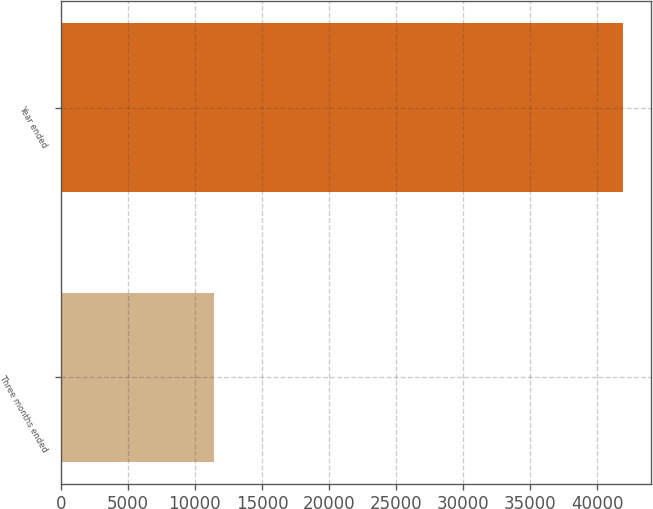<chart> <loc_0><loc_0><loc_500><loc_500><bar_chart><fcel>Three months ended<fcel>Year ended<nl><fcel>11456<fcel>41892<nl></chart> 